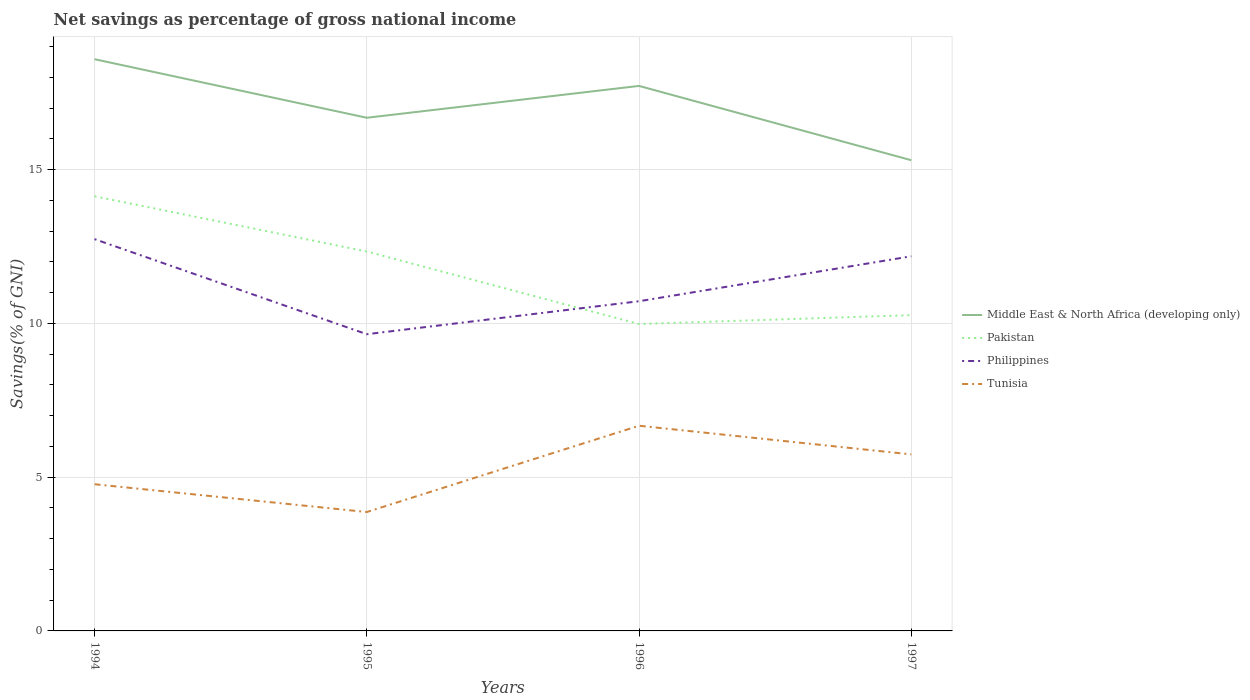Does the line corresponding to Middle East & North Africa (developing only) intersect with the line corresponding to Philippines?
Keep it short and to the point. No. Is the number of lines equal to the number of legend labels?
Your answer should be very brief. Yes. Across all years, what is the maximum total savings in Middle East & North Africa (developing only)?
Your response must be concise. 15.31. In which year was the total savings in Middle East & North Africa (developing only) maximum?
Keep it short and to the point. 1997. What is the total total savings in Pakistan in the graph?
Offer a very short reply. 4.15. What is the difference between the highest and the second highest total savings in Pakistan?
Your answer should be compact. 4.15. What is the difference between the highest and the lowest total savings in Philippines?
Provide a short and direct response. 2. Is the total savings in Philippines strictly greater than the total savings in Tunisia over the years?
Offer a terse response. No. How many lines are there?
Offer a very short reply. 4. How many years are there in the graph?
Keep it short and to the point. 4. What is the difference between two consecutive major ticks on the Y-axis?
Offer a very short reply. 5. Does the graph contain grids?
Ensure brevity in your answer.  Yes. How many legend labels are there?
Your response must be concise. 4. How are the legend labels stacked?
Provide a succinct answer. Vertical. What is the title of the graph?
Give a very brief answer. Net savings as percentage of gross national income. What is the label or title of the Y-axis?
Your answer should be compact. Savings(% of GNI). What is the Savings(% of GNI) of Middle East & North Africa (developing only) in 1994?
Keep it short and to the point. 18.59. What is the Savings(% of GNI) of Pakistan in 1994?
Your answer should be compact. 14.13. What is the Savings(% of GNI) of Philippines in 1994?
Your answer should be compact. 12.74. What is the Savings(% of GNI) of Tunisia in 1994?
Give a very brief answer. 4.77. What is the Savings(% of GNI) in Middle East & North Africa (developing only) in 1995?
Ensure brevity in your answer.  16.69. What is the Savings(% of GNI) of Pakistan in 1995?
Make the answer very short. 12.34. What is the Savings(% of GNI) of Philippines in 1995?
Keep it short and to the point. 9.65. What is the Savings(% of GNI) of Tunisia in 1995?
Offer a very short reply. 3.87. What is the Savings(% of GNI) in Middle East & North Africa (developing only) in 1996?
Keep it short and to the point. 17.72. What is the Savings(% of GNI) of Pakistan in 1996?
Your answer should be compact. 9.98. What is the Savings(% of GNI) in Philippines in 1996?
Keep it short and to the point. 10.72. What is the Savings(% of GNI) in Tunisia in 1996?
Your response must be concise. 6.67. What is the Savings(% of GNI) in Middle East & North Africa (developing only) in 1997?
Give a very brief answer. 15.31. What is the Savings(% of GNI) in Pakistan in 1997?
Ensure brevity in your answer.  10.27. What is the Savings(% of GNI) of Philippines in 1997?
Offer a terse response. 12.18. What is the Savings(% of GNI) of Tunisia in 1997?
Offer a terse response. 5.74. Across all years, what is the maximum Savings(% of GNI) in Middle East & North Africa (developing only)?
Provide a succinct answer. 18.59. Across all years, what is the maximum Savings(% of GNI) of Pakistan?
Offer a terse response. 14.13. Across all years, what is the maximum Savings(% of GNI) in Philippines?
Offer a very short reply. 12.74. Across all years, what is the maximum Savings(% of GNI) in Tunisia?
Make the answer very short. 6.67. Across all years, what is the minimum Savings(% of GNI) in Middle East & North Africa (developing only)?
Provide a short and direct response. 15.31. Across all years, what is the minimum Savings(% of GNI) in Pakistan?
Make the answer very short. 9.98. Across all years, what is the minimum Savings(% of GNI) in Philippines?
Your response must be concise. 9.65. Across all years, what is the minimum Savings(% of GNI) of Tunisia?
Make the answer very short. 3.87. What is the total Savings(% of GNI) in Middle East & North Africa (developing only) in the graph?
Keep it short and to the point. 68.31. What is the total Savings(% of GNI) in Pakistan in the graph?
Offer a terse response. 46.72. What is the total Savings(% of GNI) in Philippines in the graph?
Make the answer very short. 45.29. What is the total Savings(% of GNI) of Tunisia in the graph?
Your answer should be compact. 21.05. What is the difference between the Savings(% of GNI) in Middle East & North Africa (developing only) in 1994 and that in 1995?
Keep it short and to the point. 1.9. What is the difference between the Savings(% of GNI) of Pakistan in 1994 and that in 1995?
Offer a very short reply. 1.8. What is the difference between the Savings(% of GNI) of Philippines in 1994 and that in 1995?
Provide a succinct answer. 3.09. What is the difference between the Savings(% of GNI) of Tunisia in 1994 and that in 1995?
Offer a terse response. 0.9. What is the difference between the Savings(% of GNI) of Middle East & North Africa (developing only) in 1994 and that in 1996?
Your answer should be very brief. 0.87. What is the difference between the Savings(% of GNI) in Pakistan in 1994 and that in 1996?
Your answer should be very brief. 4.15. What is the difference between the Savings(% of GNI) in Philippines in 1994 and that in 1996?
Your answer should be very brief. 2.02. What is the difference between the Savings(% of GNI) of Tunisia in 1994 and that in 1996?
Offer a terse response. -1.9. What is the difference between the Savings(% of GNI) of Middle East & North Africa (developing only) in 1994 and that in 1997?
Make the answer very short. 3.28. What is the difference between the Savings(% of GNI) in Pakistan in 1994 and that in 1997?
Keep it short and to the point. 3.87. What is the difference between the Savings(% of GNI) in Philippines in 1994 and that in 1997?
Provide a succinct answer. 0.56. What is the difference between the Savings(% of GNI) of Tunisia in 1994 and that in 1997?
Your answer should be compact. -0.97. What is the difference between the Savings(% of GNI) of Middle East & North Africa (developing only) in 1995 and that in 1996?
Offer a very short reply. -1.04. What is the difference between the Savings(% of GNI) in Pakistan in 1995 and that in 1996?
Ensure brevity in your answer.  2.36. What is the difference between the Savings(% of GNI) in Philippines in 1995 and that in 1996?
Give a very brief answer. -1.07. What is the difference between the Savings(% of GNI) of Tunisia in 1995 and that in 1996?
Provide a succinct answer. -2.81. What is the difference between the Savings(% of GNI) of Middle East & North Africa (developing only) in 1995 and that in 1997?
Provide a short and direct response. 1.38. What is the difference between the Savings(% of GNI) in Pakistan in 1995 and that in 1997?
Your response must be concise. 2.07. What is the difference between the Savings(% of GNI) of Philippines in 1995 and that in 1997?
Make the answer very short. -2.53. What is the difference between the Savings(% of GNI) in Tunisia in 1995 and that in 1997?
Offer a very short reply. -1.87. What is the difference between the Savings(% of GNI) of Middle East & North Africa (developing only) in 1996 and that in 1997?
Your answer should be compact. 2.42. What is the difference between the Savings(% of GNI) in Pakistan in 1996 and that in 1997?
Provide a succinct answer. -0.29. What is the difference between the Savings(% of GNI) in Philippines in 1996 and that in 1997?
Your answer should be compact. -1.46. What is the difference between the Savings(% of GNI) in Tunisia in 1996 and that in 1997?
Offer a terse response. 0.93. What is the difference between the Savings(% of GNI) in Middle East & North Africa (developing only) in 1994 and the Savings(% of GNI) in Pakistan in 1995?
Provide a short and direct response. 6.25. What is the difference between the Savings(% of GNI) in Middle East & North Africa (developing only) in 1994 and the Savings(% of GNI) in Philippines in 1995?
Provide a short and direct response. 8.94. What is the difference between the Savings(% of GNI) of Middle East & North Africa (developing only) in 1994 and the Savings(% of GNI) of Tunisia in 1995?
Ensure brevity in your answer.  14.72. What is the difference between the Savings(% of GNI) of Pakistan in 1994 and the Savings(% of GNI) of Philippines in 1995?
Provide a short and direct response. 4.49. What is the difference between the Savings(% of GNI) of Pakistan in 1994 and the Savings(% of GNI) of Tunisia in 1995?
Provide a succinct answer. 10.27. What is the difference between the Savings(% of GNI) of Philippines in 1994 and the Savings(% of GNI) of Tunisia in 1995?
Provide a succinct answer. 8.87. What is the difference between the Savings(% of GNI) of Middle East & North Africa (developing only) in 1994 and the Savings(% of GNI) of Pakistan in 1996?
Offer a terse response. 8.61. What is the difference between the Savings(% of GNI) of Middle East & North Africa (developing only) in 1994 and the Savings(% of GNI) of Philippines in 1996?
Offer a terse response. 7.87. What is the difference between the Savings(% of GNI) of Middle East & North Africa (developing only) in 1994 and the Savings(% of GNI) of Tunisia in 1996?
Keep it short and to the point. 11.92. What is the difference between the Savings(% of GNI) in Pakistan in 1994 and the Savings(% of GNI) in Philippines in 1996?
Make the answer very short. 3.41. What is the difference between the Savings(% of GNI) of Pakistan in 1994 and the Savings(% of GNI) of Tunisia in 1996?
Give a very brief answer. 7.46. What is the difference between the Savings(% of GNI) in Philippines in 1994 and the Savings(% of GNI) in Tunisia in 1996?
Make the answer very short. 6.07. What is the difference between the Savings(% of GNI) of Middle East & North Africa (developing only) in 1994 and the Savings(% of GNI) of Pakistan in 1997?
Ensure brevity in your answer.  8.32. What is the difference between the Savings(% of GNI) of Middle East & North Africa (developing only) in 1994 and the Savings(% of GNI) of Philippines in 1997?
Keep it short and to the point. 6.41. What is the difference between the Savings(% of GNI) in Middle East & North Africa (developing only) in 1994 and the Savings(% of GNI) in Tunisia in 1997?
Give a very brief answer. 12.85. What is the difference between the Savings(% of GNI) in Pakistan in 1994 and the Savings(% of GNI) in Philippines in 1997?
Keep it short and to the point. 1.95. What is the difference between the Savings(% of GNI) in Pakistan in 1994 and the Savings(% of GNI) in Tunisia in 1997?
Give a very brief answer. 8.39. What is the difference between the Savings(% of GNI) in Philippines in 1994 and the Savings(% of GNI) in Tunisia in 1997?
Keep it short and to the point. 7. What is the difference between the Savings(% of GNI) of Middle East & North Africa (developing only) in 1995 and the Savings(% of GNI) of Pakistan in 1996?
Keep it short and to the point. 6.71. What is the difference between the Savings(% of GNI) of Middle East & North Africa (developing only) in 1995 and the Savings(% of GNI) of Philippines in 1996?
Offer a terse response. 5.97. What is the difference between the Savings(% of GNI) of Middle East & North Africa (developing only) in 1995 and the Savings(% of GNI) of Tunisia in 1996?
Give a very brief answer. 10.02. What is the difference between the Savings(% of GNI) in Pakistan in 1995 and the Savings(% of GNI) in Philippines in 1996?
Offer a very short reply. 1.62. What is the difference between the Savings(% of GNI) in Pakistan in 1995 and the Savings(% of GNI) in Tunisia in 1996?
Ensure brevity in your answer.  5.67. What is the difference between the Savings(% of GNI) of Philippines in 1995 and the Savings(% of GNI) of Tunisia in 1996?
Your response must be concise. 2.98. What is the difference between the Savings(% of GNI) in Middle East & North Africa (developing only) in 1995 and the Savings(% of GNI) in Pakistan in 1997?
Your response must be concise. 6.42. What is the difference between the Savings(% of GNI) in Middle East & North Africa (developing only) in 1995 and the Savings(% of GNI) in Philippines in 1997?
Offer a very short reply. 4.5. What is the difference between the Savings(% of GNI) in Middle East & North Africa (developing only) in 1995 and the Savings(% of GNI) in Tunisia in 1997?
Ensure brevity in your answer.  10.95. What is the difference between the Savings(% of GNI) in Pakistan in 1995 and the Savings(% of GNI) in Philippines in 1997?
Your answer should be very brief. 0.16. What is the difference between the Savings(% of GNI) in Pakistan in 1995 and the Savings(% of GNI) in Tunisia in 1997?
Offer a very short reply. 6.6. What is the difference between the Savings(% of GNI) of Philippines in 1995 and the Savings(% of GNI) of Tunisia in 1997?
Give a very brief answer. 3.91. What is the difference between the Savings(% of GNI) in Middle East & North Africa (developing only) in 1996 and the Savings(% of GNI) in Pakistan in 1997?
Make the answer very short. 7.45. What is the difference between the Savings(% of GNI) of Middle East & North Africa (developing only) in 1996 and the Savings(% of GNI) of Philippines in 1997?
Ensure brevity in your answer.  5.54. What is the difference between the Savings(% of GNI) in Middle East & North Africa (developing only) in 1996 and the Savings(% of GNI) in Tunisia in 1997?
Your response must be concise. 11.98. What is the difference between the Savings(% of GNI) in Pakistan in 1996 and the Savings(% of GNI) in Philippines in 1997?
Ensure brevity in your answer.  -2.2. What is the difference between the Savings(% of GNI) in Pakistan in 1996 and the Savings(% of GNI) in Tunisia in 1997?
Make the answer very short. 4.24. What is the difference between the Savings(% of GNI) in Philippines in 1996 and the Savings(% of GNI) in Tunisia in 1997?
Make the answer very short. 4.98. What is the average Savings(% of GNI) of Middle East & North Africa (developing only) per year?
Provide a succinct answer. 17.08. What is the average Savings(% of GNI) in Pakistan per year?
Make the answer very short. 11.68. What is the average Savings(% of GNI) in Philippines per year?
Offer a terse response. 11.32. What is the average Savings(% of GNI) in Tunisia per year?
Your response must be concise. 5.26. In the year 1994, what is the difference between the Savings(% of GNI) in Middle East & North Africa (developing only) and Savings(% of GNI) in Pakistan?
Provide a succinct answer. 4.46. In the year 1994, what is the difference between the Savings(% of GNI) in Middle East & North Africa (developing only) and Savings(% of GNI) in Philippines?
Offer a terse response. 5.85. In the year 1994, what is the difference between the Savings(% of GNI) of Middle East & North Africa (developing only) and Savings(% of GNI) of Tunisia?
Keep it short and to the point. 13.82. In the year 1994, what is the difference between the Savings(% of GNI) of Pakistan and Savings(% of GNI) of Philippines?
Your response must be concise. 1.39. In the year 1994, what is the difference between the Savings(% of GNI) of Pakistan and Savings(% of GNI) of Tunisia?
Your answer should be very brief. 9.36. In the year 1994, what is the difference between the Savings(% of GNI) in Philippines and Savings(% of GNI) in Tunisia?
Provide a succinct answer. 7.97. In the year 1995, what is the difference between the Savings(% of GNI) of Middle East & North Africa (developing only) and Savings(% of GNI) of Pakistan?
Offer a terse response. 4.35. In the year 1995, what is the difference between the Savings(% of GNI) of Middle East & North Africa (developing only) and Savings(% of GNI) of Philippines?
Give a very brief answer. 7.04. In the year 1995, what is the difference between the Savings(% of GNI) of Middle East & North Africa (developing only) and Savings(% of GNI) of Tunisia?
Your answer should be very brief. 12.82. In the year 1995, what is the difference between the Savings(% of GNI) in Pakistan and Savings(% of GNI) in Philippines?
Keep it short and to the point. 2.69. In the year 1995, what is the difference between the Savings(% of GNI) in Pakistan and Savings(% of GNI) in Tunisia?
Keep it short and to the point. 8.47. In the year 1995, what is the difference between the Savings(% of GNI) of Philippines and Savings(% of GNI) of Tunisia?
Give a very brief answer. 5.78. In the year 1996, what is the difference between the Savings(% of GNI) of Middle East & North Africa (developing only) and Savings(% of GNI) of Pakistan?
Offer a terse response. 7.74. In the year 1996, what is the difference between the Savings(% of GNI) in Middle East & North Africa (developing only) and Savings(% of GNI) in Philippines?
Provide a short and direct response. 7. In the year 1996, what is the difference between the Savings(% of GNI) in Middle East & North Africa (developing only) and Savings(% of GNI) in Tunisia?
Your answer should be compact. 11.05. In the year 1996, what is the difference between the Savings(% of GNI) in Pakistan and Savings(% of GNI) in Philippines?
Offer a terse response. -0.74. In the year 1996, what is the difference between the Savings(% of GNI) in Pakistan and Savings(% of GNI) in Tunisia?
Keep it short and to the point. 3.31. In the year 1996, what is the difference between the Savings(% of GNI) in Philippines and Savings(% of GNI) in Tunisia?
Provide a short and direct response. 4.05. In the year 1997, what is the difference between the Savings(% of GNI) of Middle East & North Africa (developing only) and Savings(% of GNI) of Pakistan?
Your response must be concise. 5.04. In the year 1997, what is the difference between the Savings(% of GNI) of Middle East & North Africa (developing only) and Savings(% of GNI) of Philippines?
Your answer should be compact. 3.12. In the year 1997, what is the difference between the Savings(% of GNI) of Middle East & North Africa (developing only) and Savings(% of GNI) of Tunisia?
Give a very brief answer. 9.57. In the year 1997, what is the difference between the Savings(% of GNI) of Pakistan and Savings(% of GNI) of Philippines?
Ensure brevity in your answer.  -1.91. In the year 1997, what is the difference between the Savings(% of GNI) in Pakistan and Savings(% of GNI) in Tunisia?
Offer a very short reply. 4.53. In the year 1997, what is the difference between the Savings(% of GNI) in Philippines and Savings(% of GNI) in Tunisia?
Your answer should be compact. 6.44. What is the ratio of the Savings(% of GNI) of Middle East & North Africa (developing only) in 1994 to that in 1995?
Give a very brief answer. 1.11. What is the ratio of the Savings(% of GNI) of Pakistan in 1994 to that in 1995?
Make the answer very short. 1.15. What is the ratio of the Savings(% of GNI) in Philippines in 1994 to that in 1995?
Offer a very short reply. 1.32. What is the ratio of the Savings(% of GNI) of Tunisia in 1994 to that in 1995?
Provide a succinct answer. 1.23. What is the ratio of the Savings(% of GNI) of Middle East & North Africa (developing only) in 1994 to that in 1996?
Give a very brief answer. 1.05. What is the ratio of the Savings(% of GNI) in Pakistan in 1994 to that in 1996?
Provide a succinct answer. 1.42. What is the ratio of the Savings(% of GNI) of Philippines in 1994 to that in 1996?
Your answer should be very brief. 1.19. What is the ratio of the Savings(% of GNI) of Tunisia in 1994 to that in 1996?
Provide a succinct answer. 0.71. What is the ratio of the Savings(% of GNI) of Middle East & North Africa (developing only) in 1994 to that in 1997?
Keep it short and to the point. 1.21. What is the ratio of the Savings(% of GNI) in Pakistan in 1994 to that in 1997?
Your answer should be very brief. 1.38. What is the ratio of the Savings(% of GNI) of Philippines in 1994 to that in 1997?
Provide a short and direct response. 1.05. What is the ratio of the Savings(% of GNI) in Tunisia in 1994 to that in 1997?
Offer a terse response. 0.83. What is the ratio of the Savings(% of GNI) in Middle East & North Africa (developing only) in 1995 to that in 1996?
Your answer should be very brief. 0.94. What is the ratio of the Savings(% of GNI) of Pakistan in 1995 to that in 1996?
Your answer should be very brief. 1.24. What is the ratio of the Savings(% of GNI) of Tunisia in 1995 to that in 1996?
Give a very brief answer. 0.58. What is the ratio of the Savings(% of GNI) of Middle East & North Africa (developing only) in 1995 to that in 1997?
Your answer should be compact. 1.09. What is the ratio of the Savings(% of GNI) of Pakistan in 1995 to that in 1997?
Offer a terse response. 1.2. What is the ratio of the Savings(% of GNI) of Philippines in 1995 to that in 1997?
Your response must be concise. 0.79. What is the ratio of the Savings(% of GNI) in Tunisia in 1995 to that in 1997?
Keep it short and to the point. 0.67. What is the ratio of the Savings(% of GNI) of Middle East & North Africa (developing only) in 1996 to that in 1997?
Offer a terse response. 1.16. What is the ratio of the Savings(% of GNI) of Pakistan in 1996 to that in 1997?
Keep it short and to the point. 0.97. What is the ratio of the Savings(% of GNI) of Tunisia in 1996 to that in 1997?
Your answer should be compact. 1.16. What is the difference between the highest and the second highest Savings(% of GNI) of Middle East & North Africa (developing only)?
Your answer should be very brief. 0.87. What is the difference between the highest and the second highest Savings(% of GNI) of Pakistan?
Make the answer very short. 1.8. What is the difference between the highest and the second highest Savings(% of GNI) in Philippines?
Make the answer very short. 0.56. What is the difference between the highest and the second highest Savings(% of GNI) of Tunisia?
Ensure brevity in your answer.  0.93. What is the difference between the highest and the lowest Savings(% of GNI) of Middle East & North Africa (developing only)?
Keep it short and to the point. 3.28. What is the difference between the highest and the lowest Savings(% of GNI) in Pakistan?
Keep it short and to the point. 4.15. What is the difference between the highest and the lowest Savings(% of GNI) of Philippines?
Provide a short and direct response. 3.09. What is the difference between the highest and the lowest Savings(% of GNI) in Tunisia?
Offer a terse response. 2.81. 